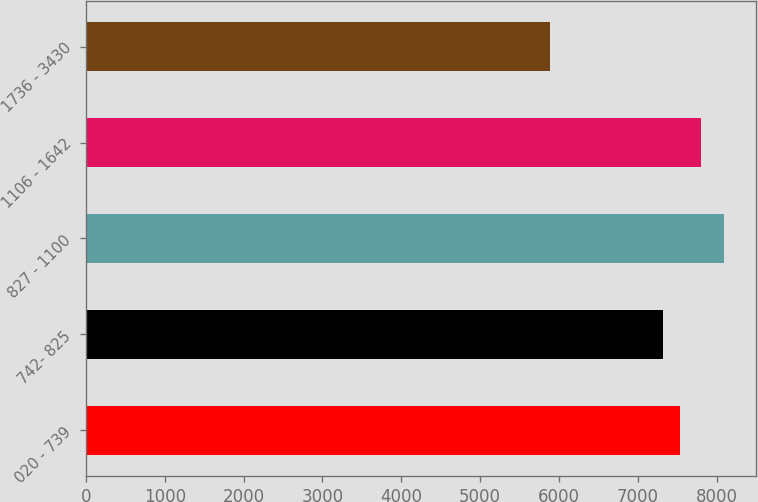Convert chart to OTSL. <chart><loc_0><loc_0><loc_500><loc_500><bar_chart><fcel>020 - 739<fcel>742- 825<fcel>827 - 1100<fcel>1106 - 1642<fcel>1736 - 3430<nl><fcel>7534<fcel>7313<fcel>8095<fcel>7795<fcel>5885<nl></chart> 